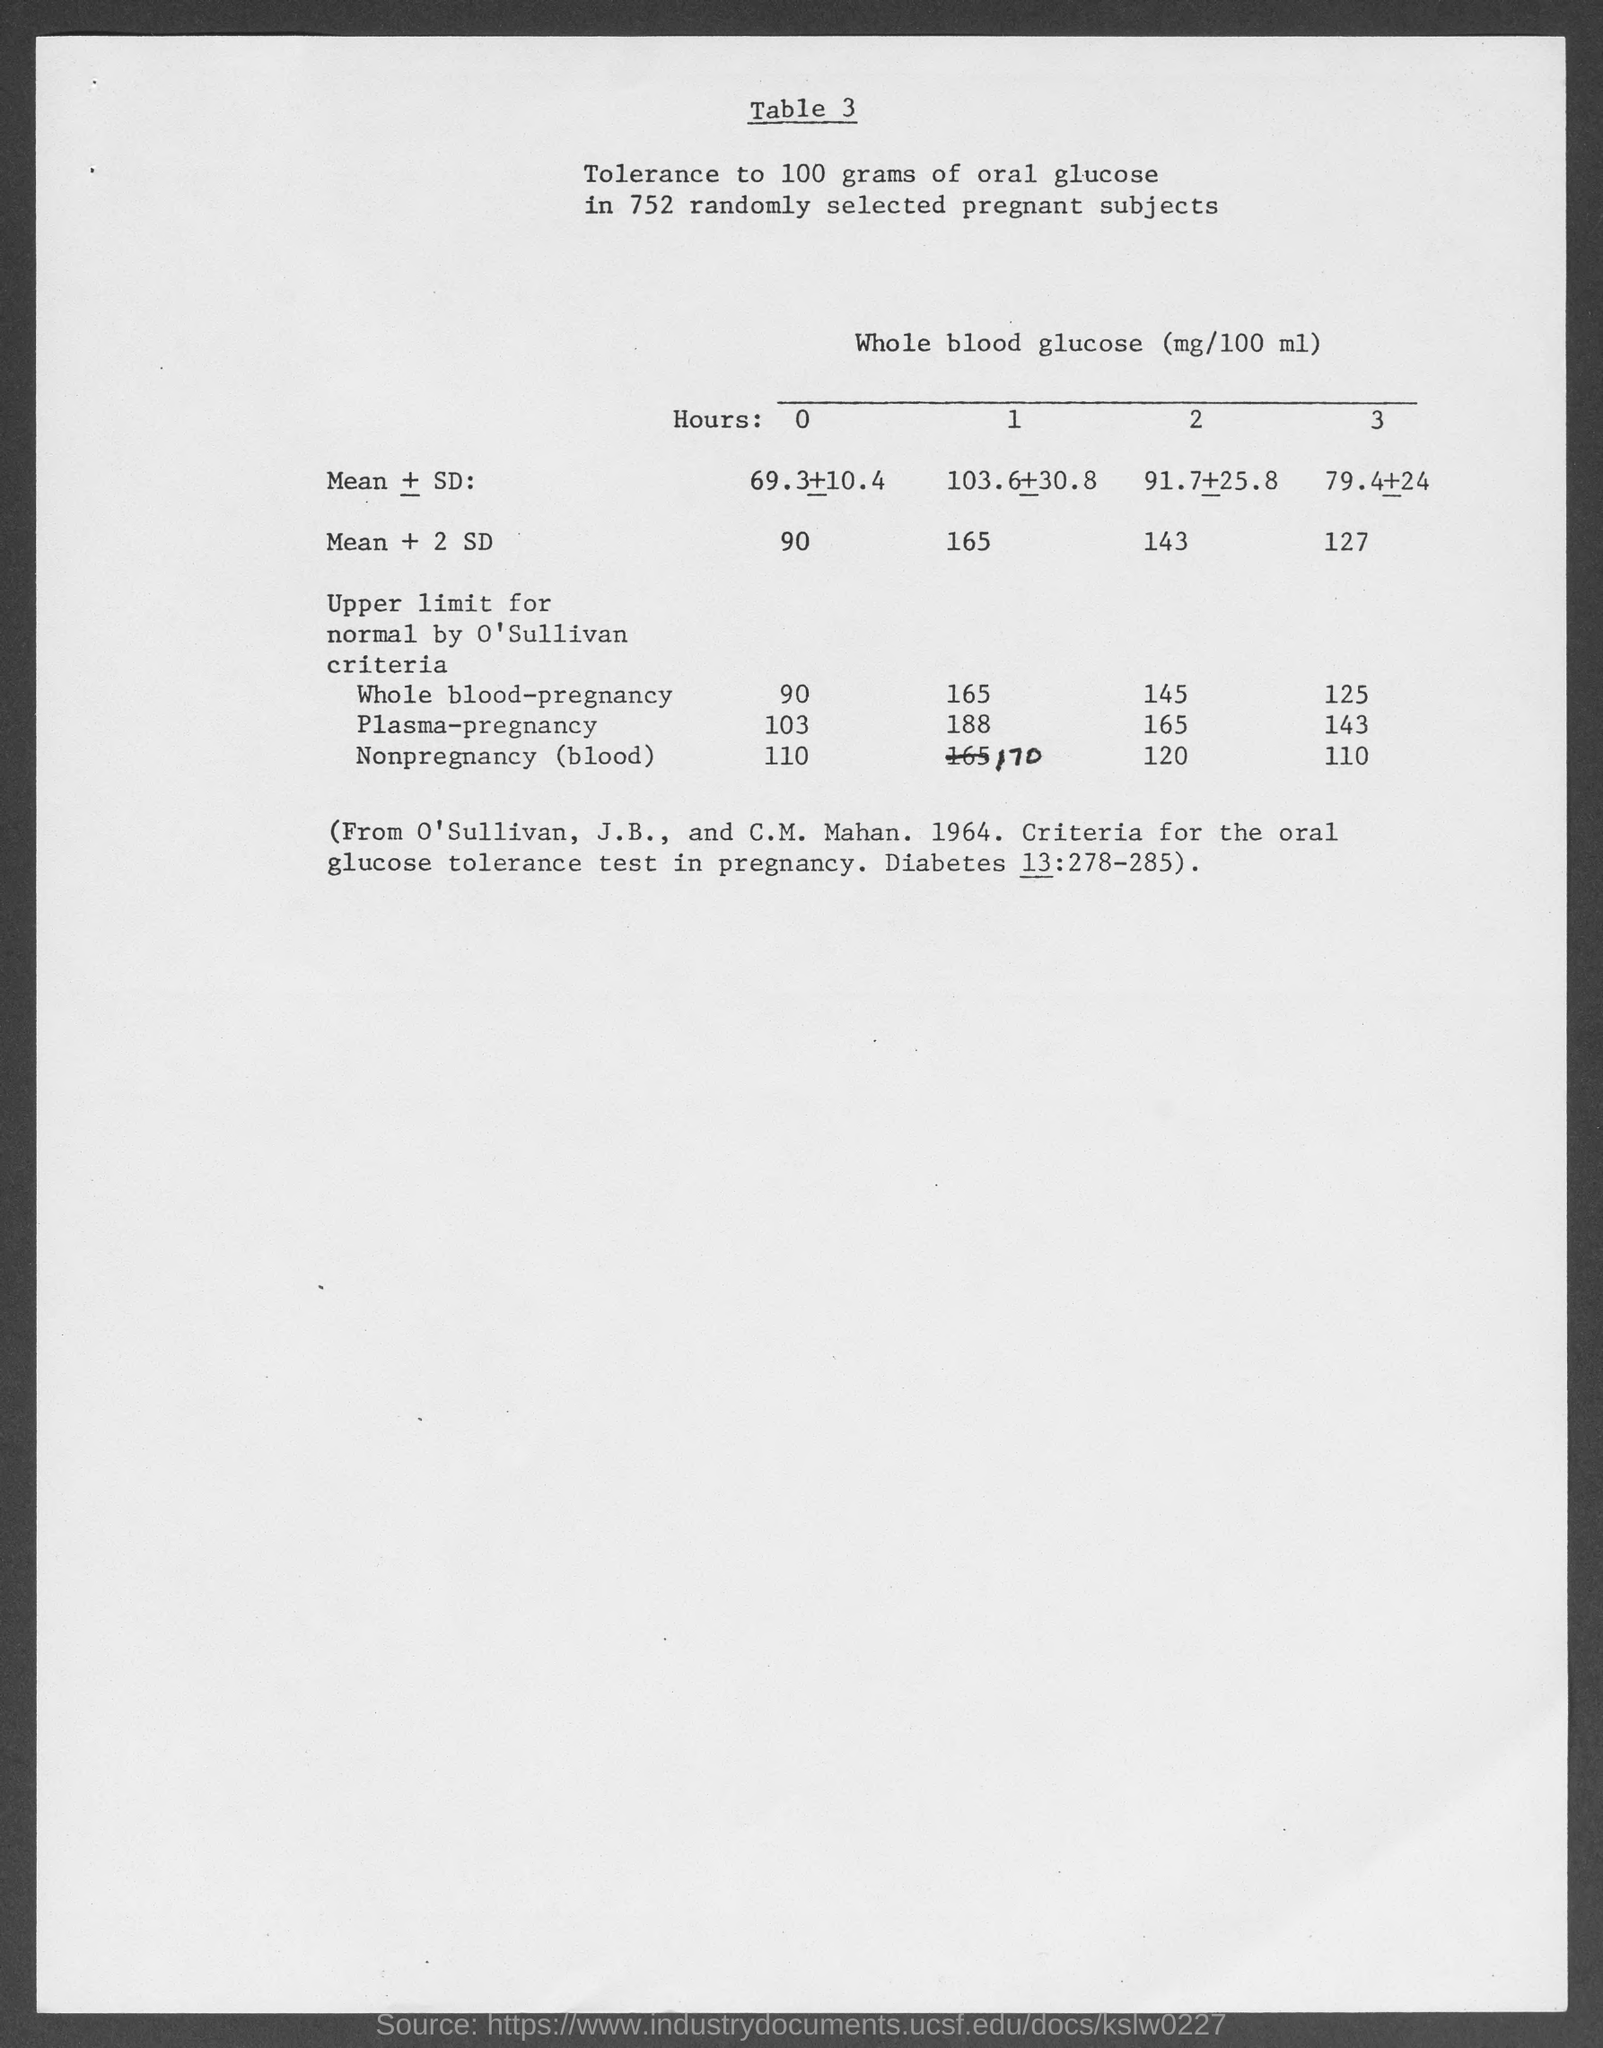What is the table no.?
Keep it short and to the point. 3. 